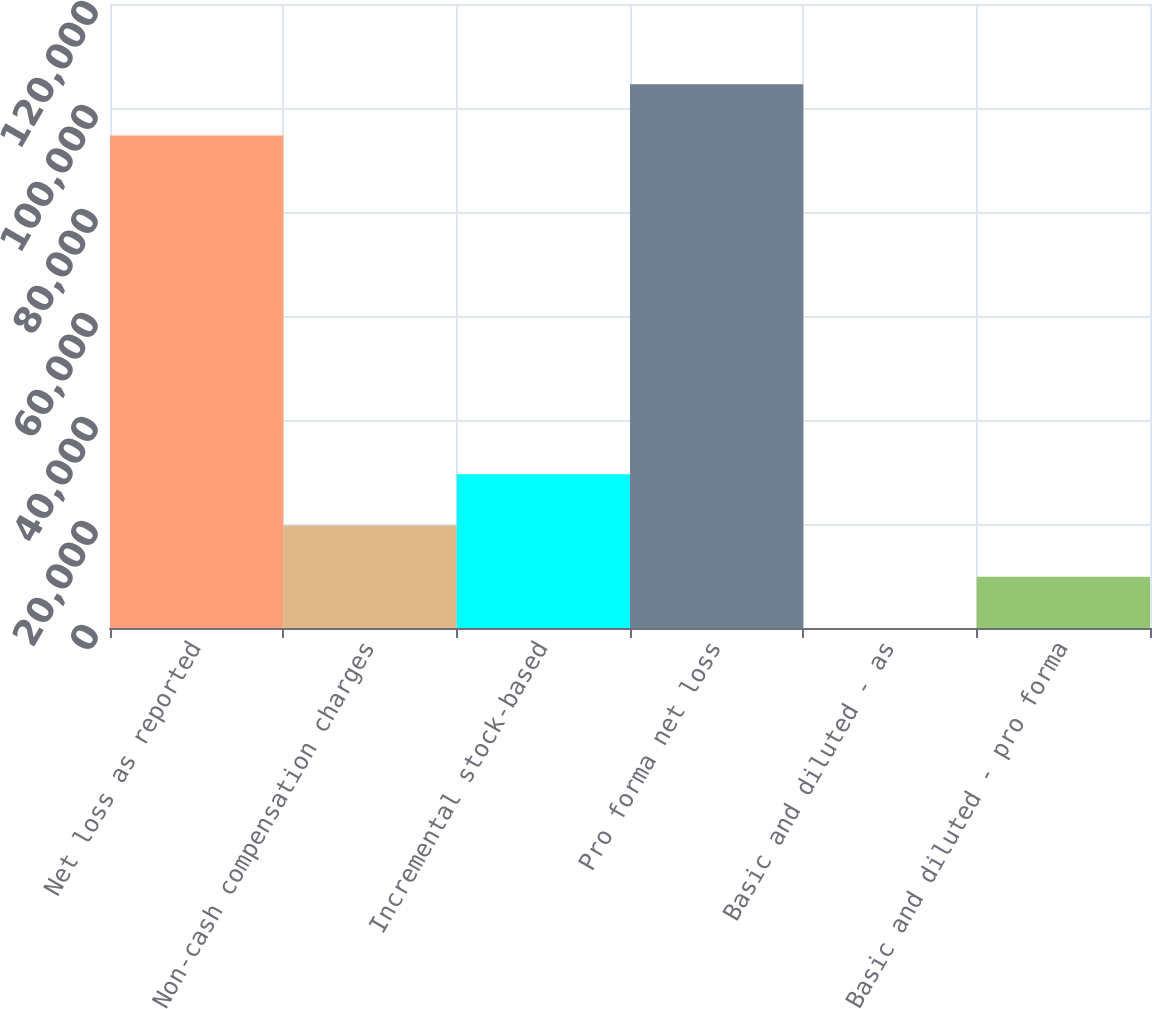Convert chart. <chart><loc_0><loc_0><loc_500><loc_500><bar_chart><fcel>Net loss as reported<fcel>Non-cash compensation charges<fcel>Incremental stock-based<fcel>Pro forma net loss<fcel>Basic and diluted - as<fcel>Basic and diluted - pro forma<nl><fcel>94709<fcel>19699.8<fcel>29549.1<fcel>104558<fcel>1.28<fcel>9850.55<nl></chart> 